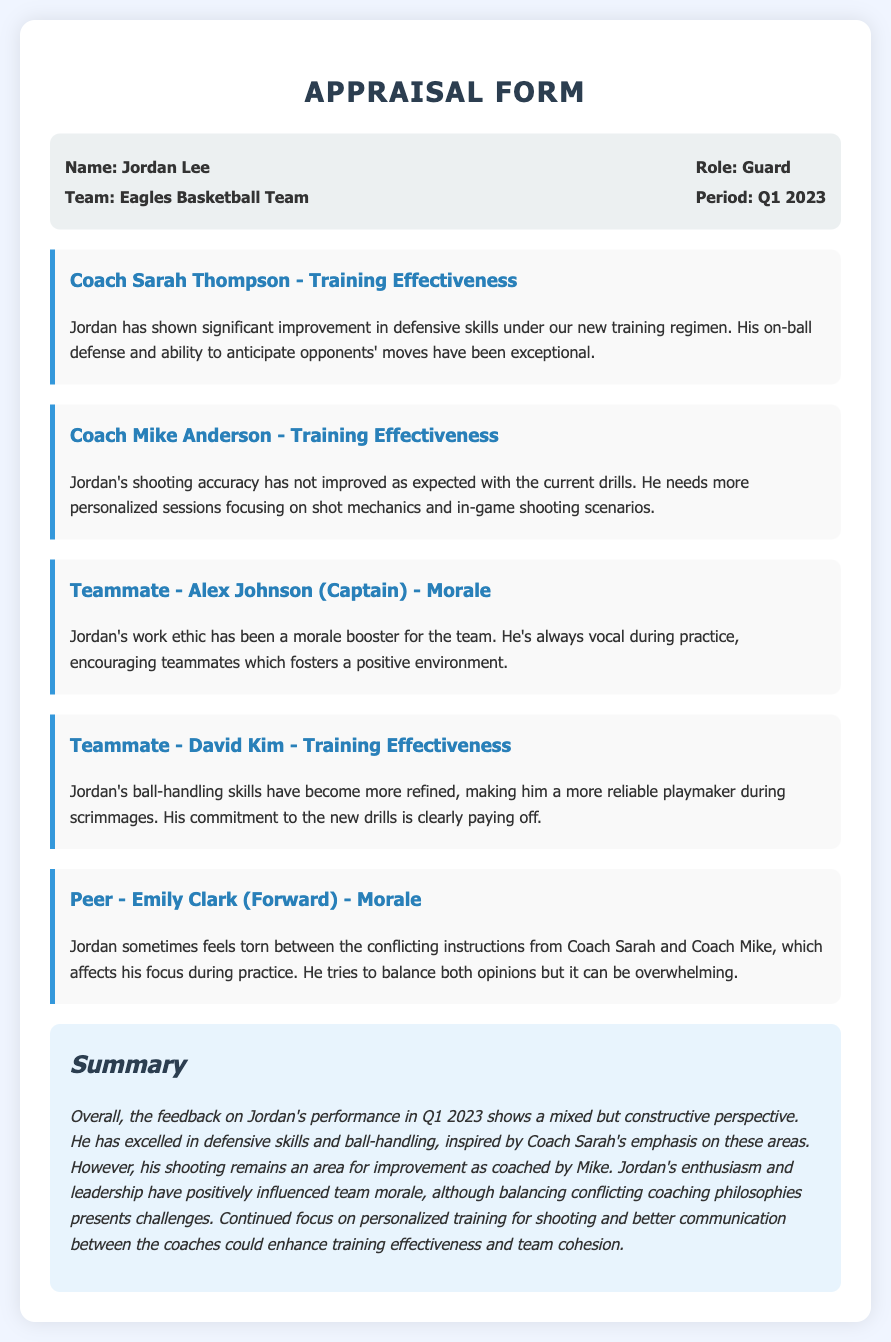what is the name of the athlete? The name of the athlete is mentioned in the header of the document.
Answer: Jordan Lee which team does Jordan play for? The team name is provided in the information section of the document.
Answer: Eagles Basketball Team what is Jordan's role in the team? Jordan's role is stated in the information section of the document.
Answer: Guard who provided feedback on Jordan's shooting accuracy? The coach's feedback on shooting accuracy is specifically mentioned in the coaching sections of the document.
Answer: Coach Mike Anderson how has Jordan contributed to team morale? The contribution to team morale is described in the feedback section from a teammate.
Answer: Vocal during practice which skill has shown significant improvement according to Coach Sarah? The specific skill that Coach Sarah highlights as improved is recorded in her feedback.
Answer: Defensive skills what area needs more personalized training for Jordan? The area requiring more personalized training is indicated in the feedback section by Coach Mike.
Answer: Shooting how did Emily Clark describe Jordan's feelings about the conflicting instructions? Emily's description of Jordan's feelings is included in the feedback section related to morale.
Answer: Torn between conflicting instructions summarize the overall feedback perspective on Jordan's performance in Q1 2023. The summary section provides a general overview of feedback on Jordan's performance focusing on strengths and areas for improvement.
Answer: Mixed but constructive perspective 